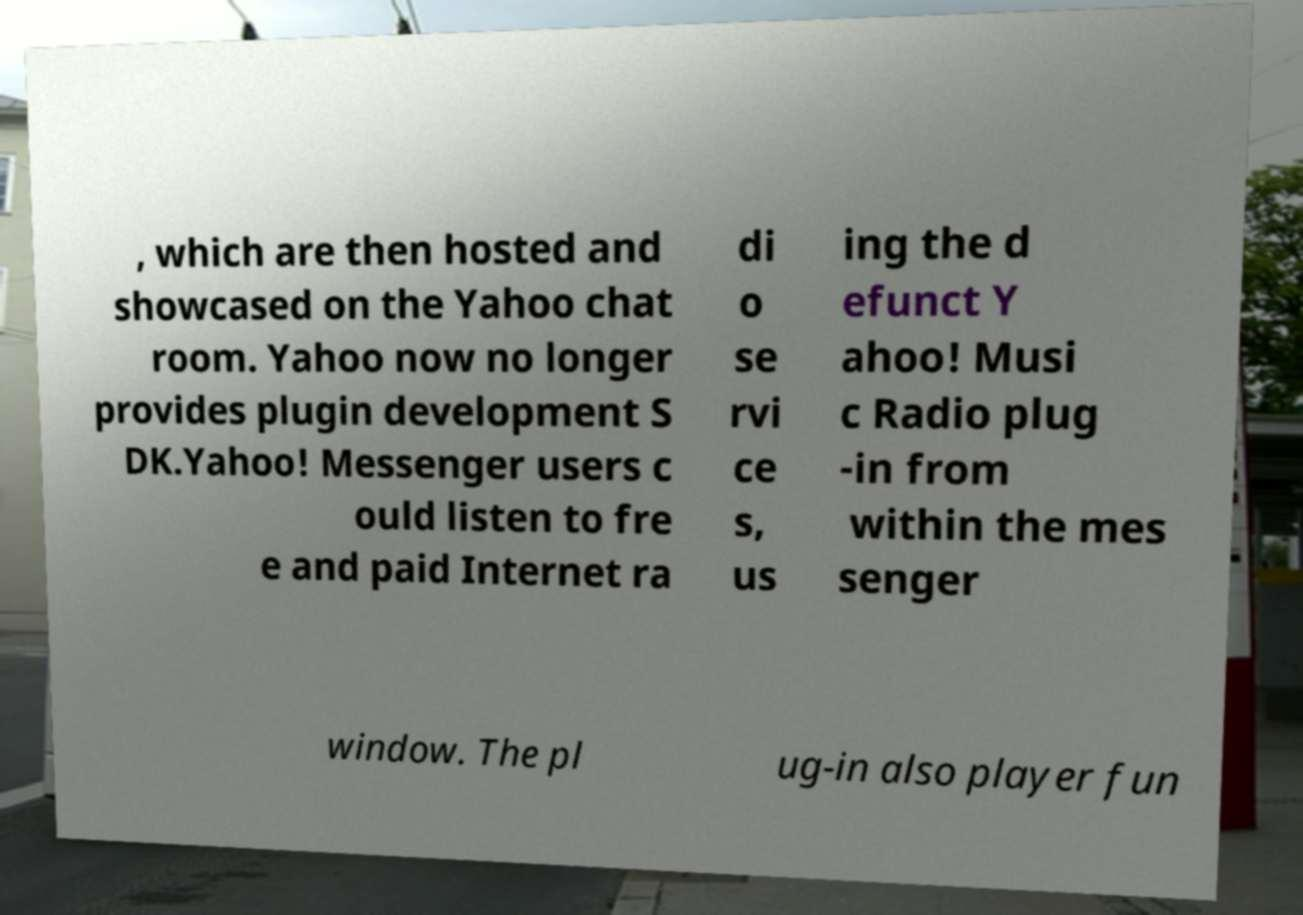Please read and relay the text visible in this image. What does it say? , which are then hosted and showcased on the Yahoo chat room. Yahoo now no longer provides plugin development S DK.Yahoo! Messenger users c ould listen to fre e and paid Internet ra di o se rvi ce s, us ing the d efunct Y ahoo! Musi c Radio plug -in from within the mes senger window. The pl ug-in also player fun 